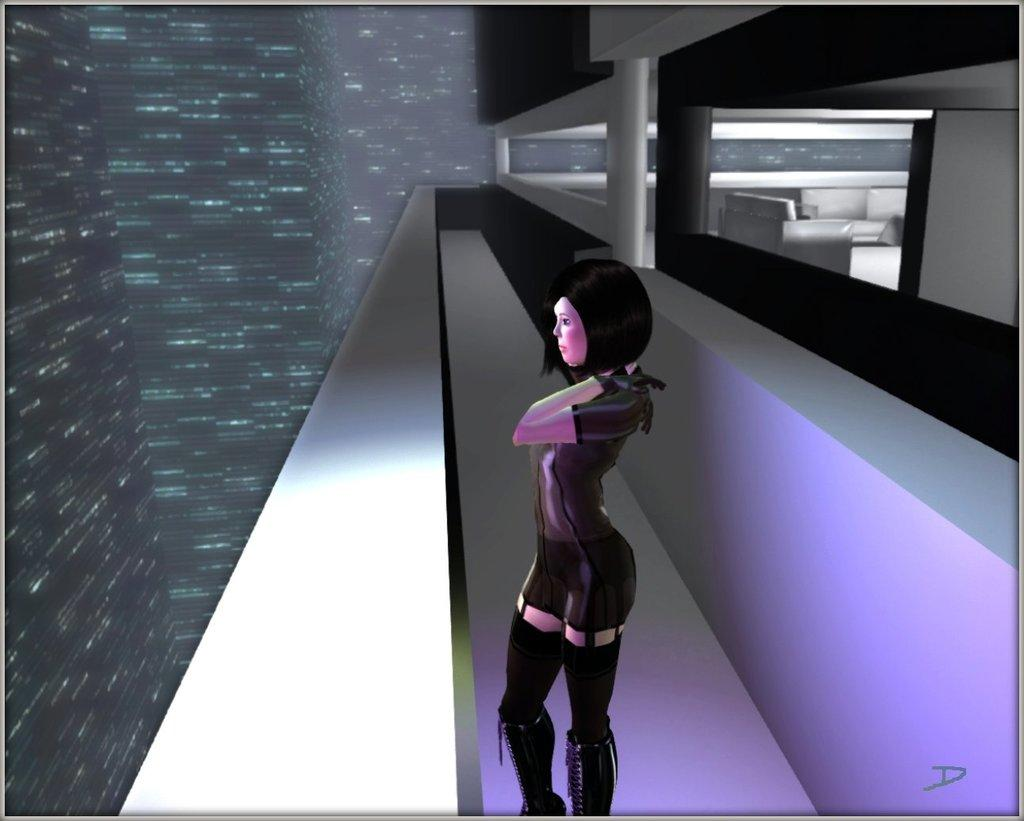What is the main subject of the image? The main subject of the image is an animation of a building. Are there any people in the image? Yes, there is a woman in the image. What is the woman wearing? The woman is wearing a black dress. What type of furniture is present in the image? There is a sofa in the image. What type of game is the woman playing in the image? There is no game present in the image; it features an animation of a building, a woman wearing a black dress, and a sofa. 